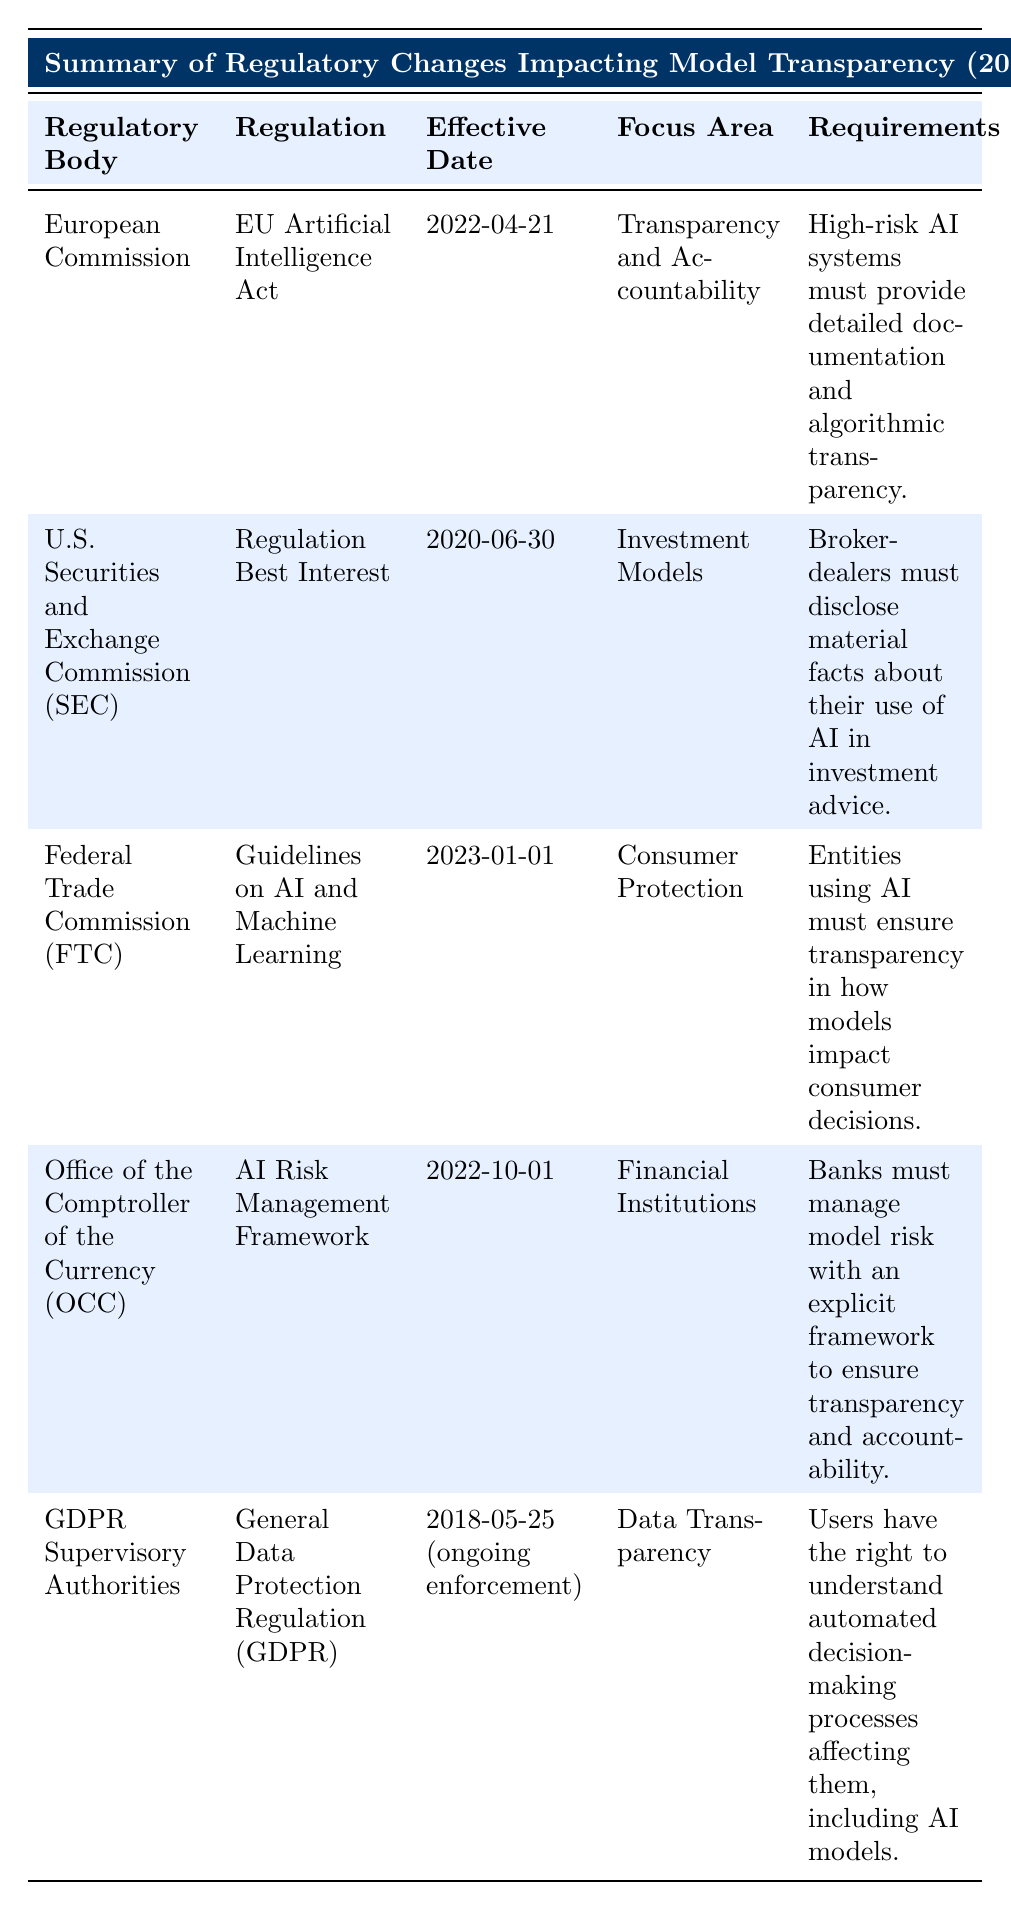What is the regulation enacted by the U.S. Securities and Exchange Commission? The table lists that the regulation enacted by the U.S. Securities and Exchange Commission is "Regulation Best Interest."
Answer: Regulation Best Interest What is the effective date of the EU Artificial Intelligence Act? According to the table, the effective date of the EU Artificial Intelligence Act is "2022-04-21."
Answer: 2022-04-21 Which regulatory body focuses on consumer protection related to AI? The table indicates that the Federal Trade Commission focuses on consumer protection related to AI, as stated in "focus area" for the regulation "Guidelines on AI and Machine Learning."
Answer: Federal Trade Commission Are banks required to manage model risk according to any regulation? Yes, the table shows that the Office of the Comptroller of the Currency has a regulation called the "AI Risk Management Framework," which requires banks to manage model risk with an explicit framework.
Answer: Yes Which regulation requires broker-dealers to disclose material facts regarding AI? The table states that the regulation "Regulation Best Interest" enacted by the U.S. Securities and Exchange Commission requires broker-dealers to disclose material facts about their use of AI in investment advice.
Answer: Regulation Best Interest Which regulation has an ongoing enforcement date since May 25, 2018? The table reveals that the General Data Protection Regulation (GDPR) has been under ongoing enforcement since May 25, 2018.
Answer: General Data Protection Regulation (GDPR) What are the requirements for high-risk AI systems under the EU Artificial Intelligence Act? The table indicates that high-risk AI systems must provide detailed documentation and algorithmic transparency as per the requirements of the EU Artificial Intelligence Act.
Answer: Detailed documentation and algorithmic transparency What is the difference in effective dates between the AI Risk Management Framework and the Guidelines on AI and Machine Learning? The effective date of the AI Risk Management Framework is 2022-10-01 and the effective date of the Guidelines on AI and Machine Learning is 2023-01-01. To find the difference, we calculate 2023-01-01 to 2022-10-01, which is approximately 3 months.
Answer: 3 months What are the focus areas of the EU Artificial Intelligence Act and the AI Risk Management Framework? The EU Artificial Intelligence Act focuses on "Transparency and Accountability," while the AI Risk Management Framework focuses on "Financial Institutions." Thus, they cover different areas.
Answer: Transparency and Accountability; Financial Institutions 